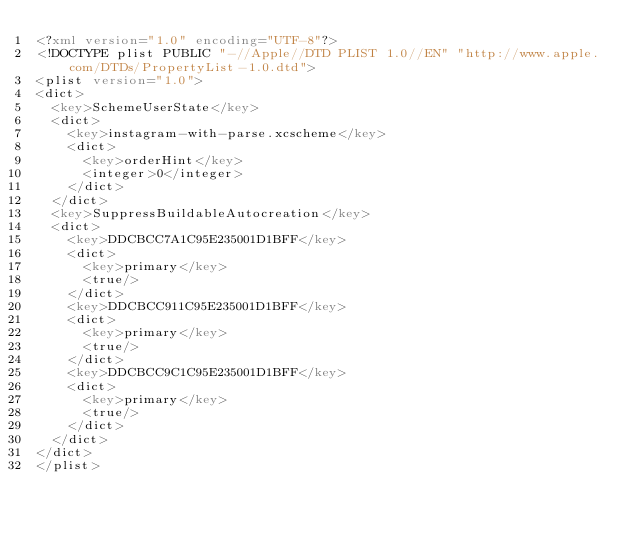Convert code to text. <code><loc_0><loc_0><loc_500><loc_500><_XML_><?xml version="1.0" encoding="UTF-8"?>
<!DOCTYPE plist PUBLIC "-//Apple//DTD PLIST 1.0//EN" "http://www.apple.com/DTDs/PropertyList-1.0.dtd">
<plist version="1.0">
<dict>
	<key>SchemeUserState</key>
	<dict>
		<key>instagram-with-parse.xcscheme</key>
		<dict>
			<key>orderHint</key>
			<integer>0</integer>
		</dict>
	</dict>
	<key>SuppressBuildableAutocreation</key>
	<dict>
		<key>DDCBCC7A1C95E235001D1BFF</key>
		<dict>
			<key>primary</key>
			<true/>
		</dict>
		<key>DDCBCC911C95E235001D1BFF</key>
		<dict>
			<key>primary</key>
			<true/>
		</dict>
		<key>DDCBCC9C1C95E235001D1BFF</key>
		<dict>
			<key>primary</key>
			<true/>
		</dict>
	</dict>
</dict>
</plist>
</code> 